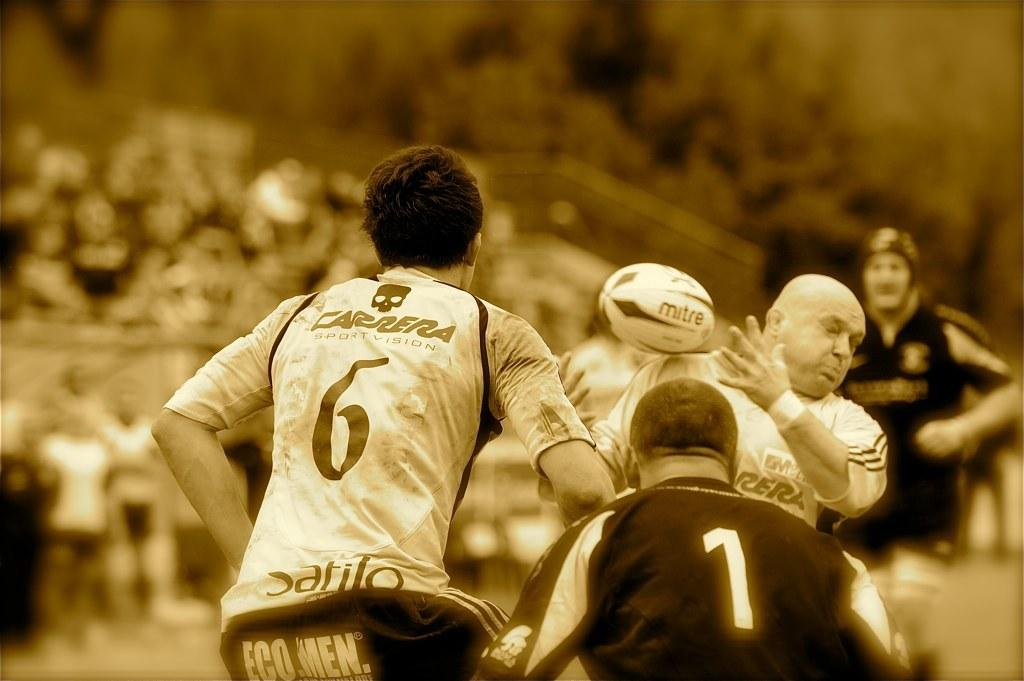<image>
Render a clear and concise summary of the photo. One of the rugby players has the number 6 on his back 